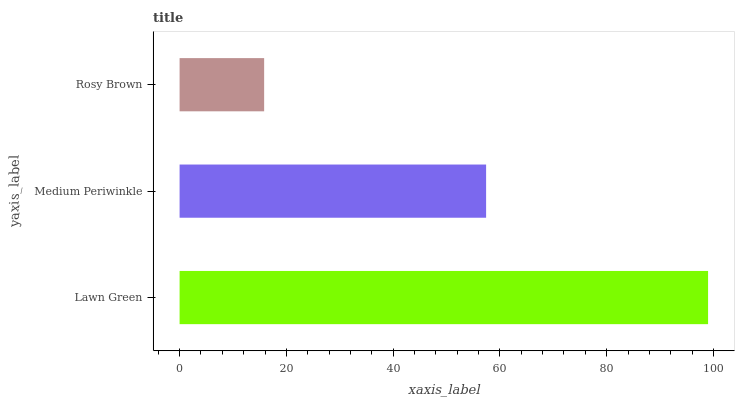Is Rosy Brown the minimum?
Answer yes or no. Yes. Is Lawn Green the maximum?
Answer yes or no. Yes. Is Medium Periwinkle the minimum?
Answer yes or no. No. Is Medium Periwinkle the maximum?
Answer yes or no. No. Is Lawn Green greater than Medium Periwinkle?
Answer yes or no. Yes. Is Medium Periwinkle less than Lawn Green?
Answer yes or no. Yes. Is Medium Periwinkle greater than Lawn Green?
Answer yes or no. No. Is Lawn Green less than Medium Periwinkle?
Answer yes or no. No. Is Medium Periwinkle the high median?
Answer yes or no. Yes. Is Medium Periwinkle the low median?
Answer yes or no. Yes. Is Rosy Brown the high median?
Answer yes or no. No. Is Lawn Green the low median?
Answer yes or no. No. 